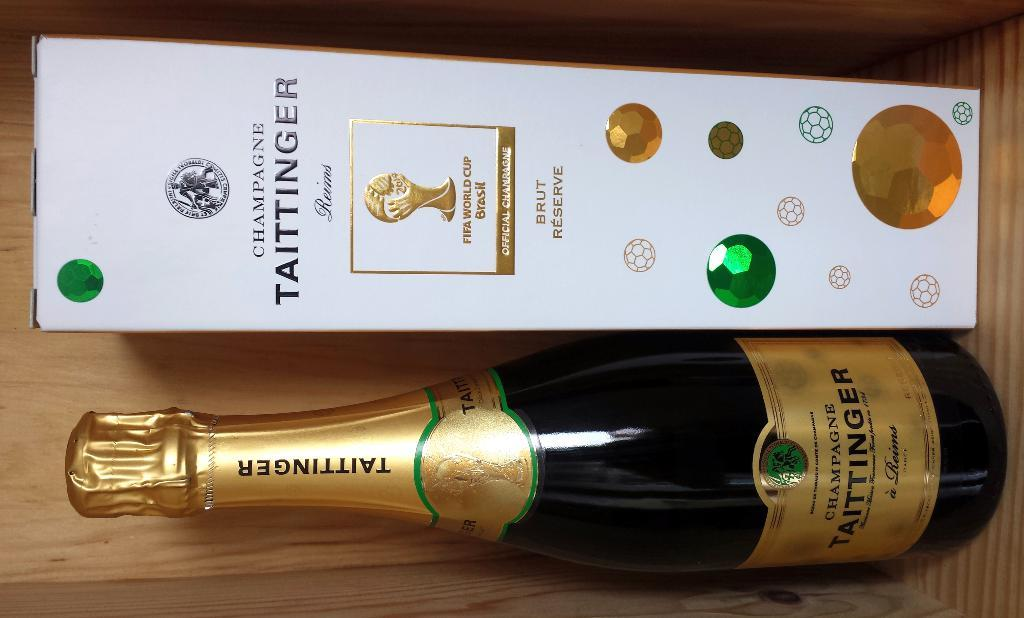<image>
Create a compact narrative representing the image presented. A bottle of "Champagne Taittinger" sits on a table 